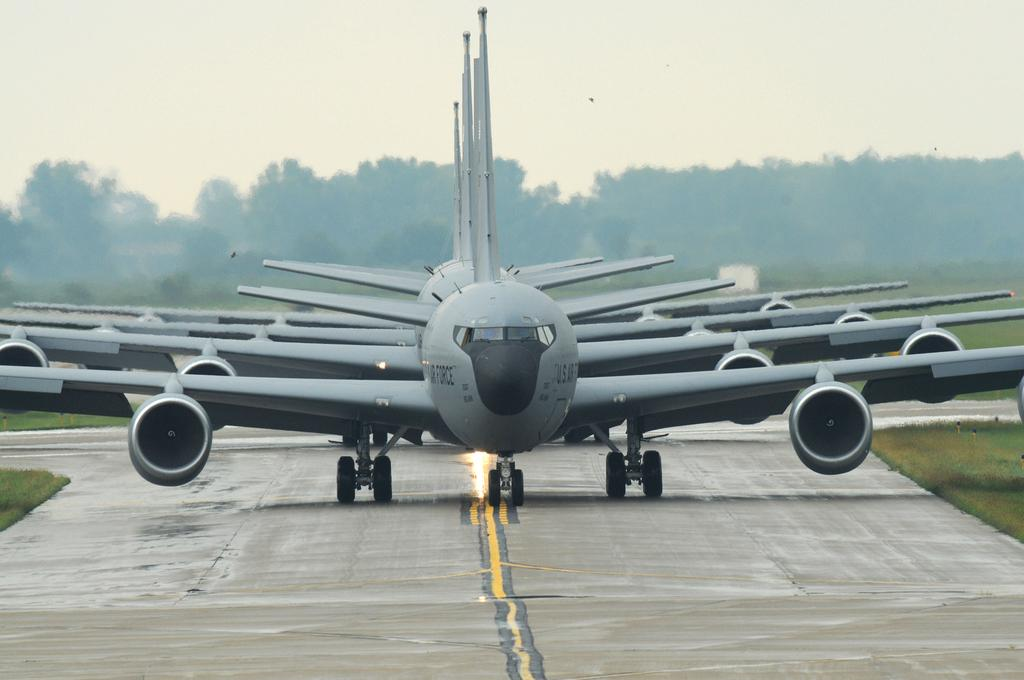What is located in the middle of the image? There are planes in the middle of the image. What type of vegetation can be seen in the image? There is grass visible in the image, and there are also trees. What is visible in the background of the image? The sky is visible in the image. What type of honey can be seen dripping from the trees in the image? There is no honey present in the image; it features planes, grass, trees, and the sky. Can you describe the beetle crawling on the planes in the image? There is no beetle present in the image; it only features planes, grass, trees, and the sky. 